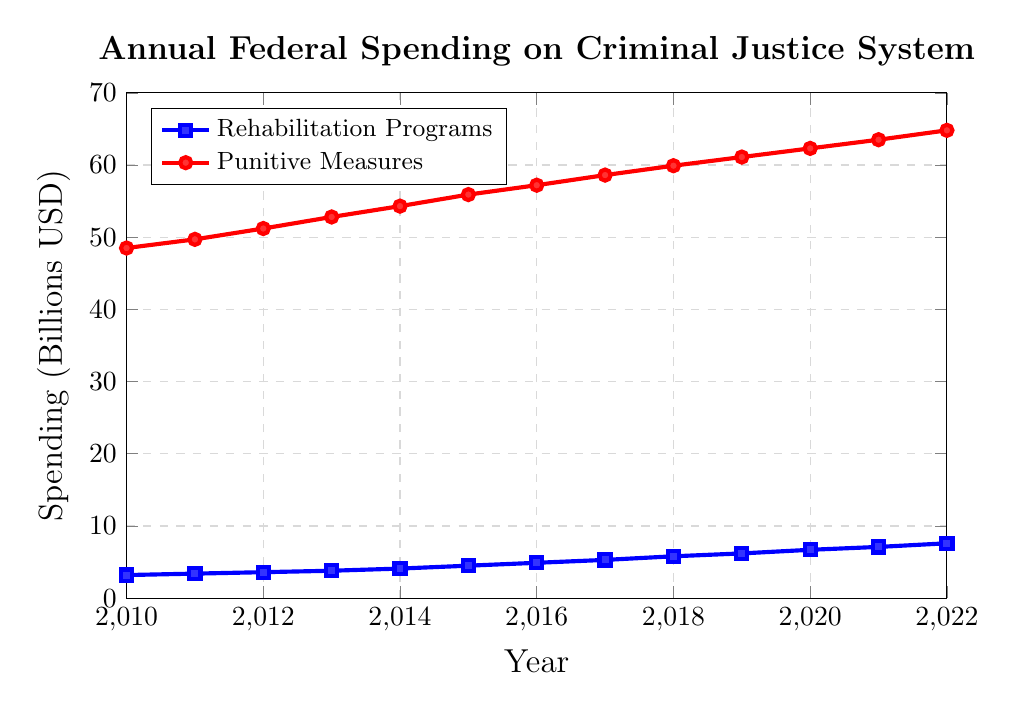what is the difference in spending on punitive measures between 2012 and 2017? To find the difference, subtract the spending in 2012 from the spending in 2017 for punitive measures: 58.6 - 51.2 = 7.4
Answer: 7.4 billion USD What was the average spending on rehabilitation programs over the observed period? Sum all the spending on rehabilitation programs and divide by the number of years: (3.2 + 3.4 + 3.6 + 3.8 + 4.1 + 4.5 + 4.9 + 5.3 + 5.8 + 6.2 + 6.7 + 7.1 + 7.6) / 13 = 59.2 / 13 ≈ 4.55
Answer: 4.55 billion USD Which year had the highest spending on rehabilitation programs, and what was the amount? Observe the data points for rehabilitation programs and identify the highest value, which occurs in 2022 with 7.6 billion USD
Answer: 2022, 7.6 billion USD Compare the growth rates of spending on rehabilitation programs and punitive measures from 2010 to 2022. Which one had a higher growth rate? Calculate the growth rate for both: Rehabilitation programs growth = (7.6 - 3.2) / 3.2 = 1.375 or 137.5%; Punitive measures growth = (64.8 - 48.5) / 48.5 = 0.335 or 33.5%. Rehabilitation programs had a higher growth rate
Answer: Rehabilitation programs: 137.5%, Punitive measures: 33.5% By how much did the spending on punitive measures exceed that on rehabilitation programs in 2021? Subtract the spending on rehabilitation programs from punitive measures in 2021: 63.5 - 7.1 = 56.4
Answer: 56.4 billion USD What is the trend in spending over the years for both categories? The line representing rehabilitation programs shows a steady increase from 3.2 billion USD in 2010 to 7.6 billion USD in 2022. Similarly, punitive measures show a consistent increase from 48.5 billion USD in 2010 to 64.8 billion USD in 2022
Answer: Both categories show an increasing trend In which year did the spending on rehabilitation programs cross the 5 billion USD mark? Identify the first year in which the value of rehabilitation programs is greater than 5 billion USD; it occurred in 2017 with 5.3 billion USD
Answer: 2017 What is the total combined spending for both categories in 2016? Add the spending on both categories for 2016: 4.9 (rehabilitation programs) + 57.2 (punitive measures) = 62.1
Answer: 62.1 billion USD In 2010, what was the ratio of spending on punitive measures to rehabilitation programs? Divide the spending on punitive measures by the spending on rehabilitation programs for 2010: 48.5 / 3.2 ≈ 15.16
Answer: 15.16 How much did the spending on rehabilitation programs increase from 2010 to 2022? Subtract the spending in 2010 from the spending in 2022 for rehabilitation programs: 7.6 - 3.2 = 4.4
Answer: 4.4 billion USD 